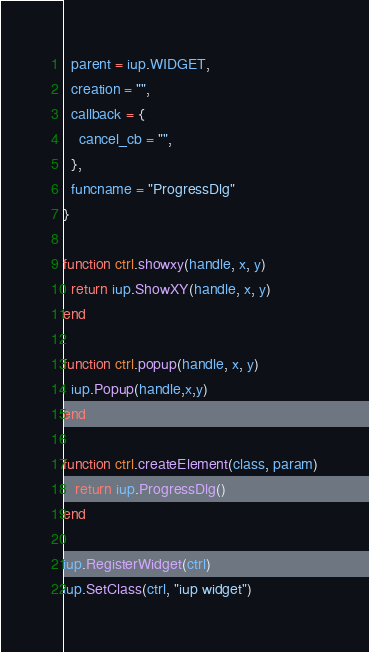Convert code to text. <code><loc_0><loc_0><loc_500><loc_500><_Lua_>  parent = iup.WIDGET,
  creation = "",
  callback = {
    cancel_cb = "",
  },
  funcname = "ProgressDlg"
} 

function ctrl.showxy(handle, x, y)
  return iup.ShowXY(handle, x, y)
end

function ctrl.popup(handle, x, y)
  iup.Popup(handle,x,y)
end

function ctrl.createElement(class, param)
   return iup.ProgressDlg()
end
   
iup.RegisterWidget(ctrl)
iup.SetClass(ctrl, "iup widget")
</code> 